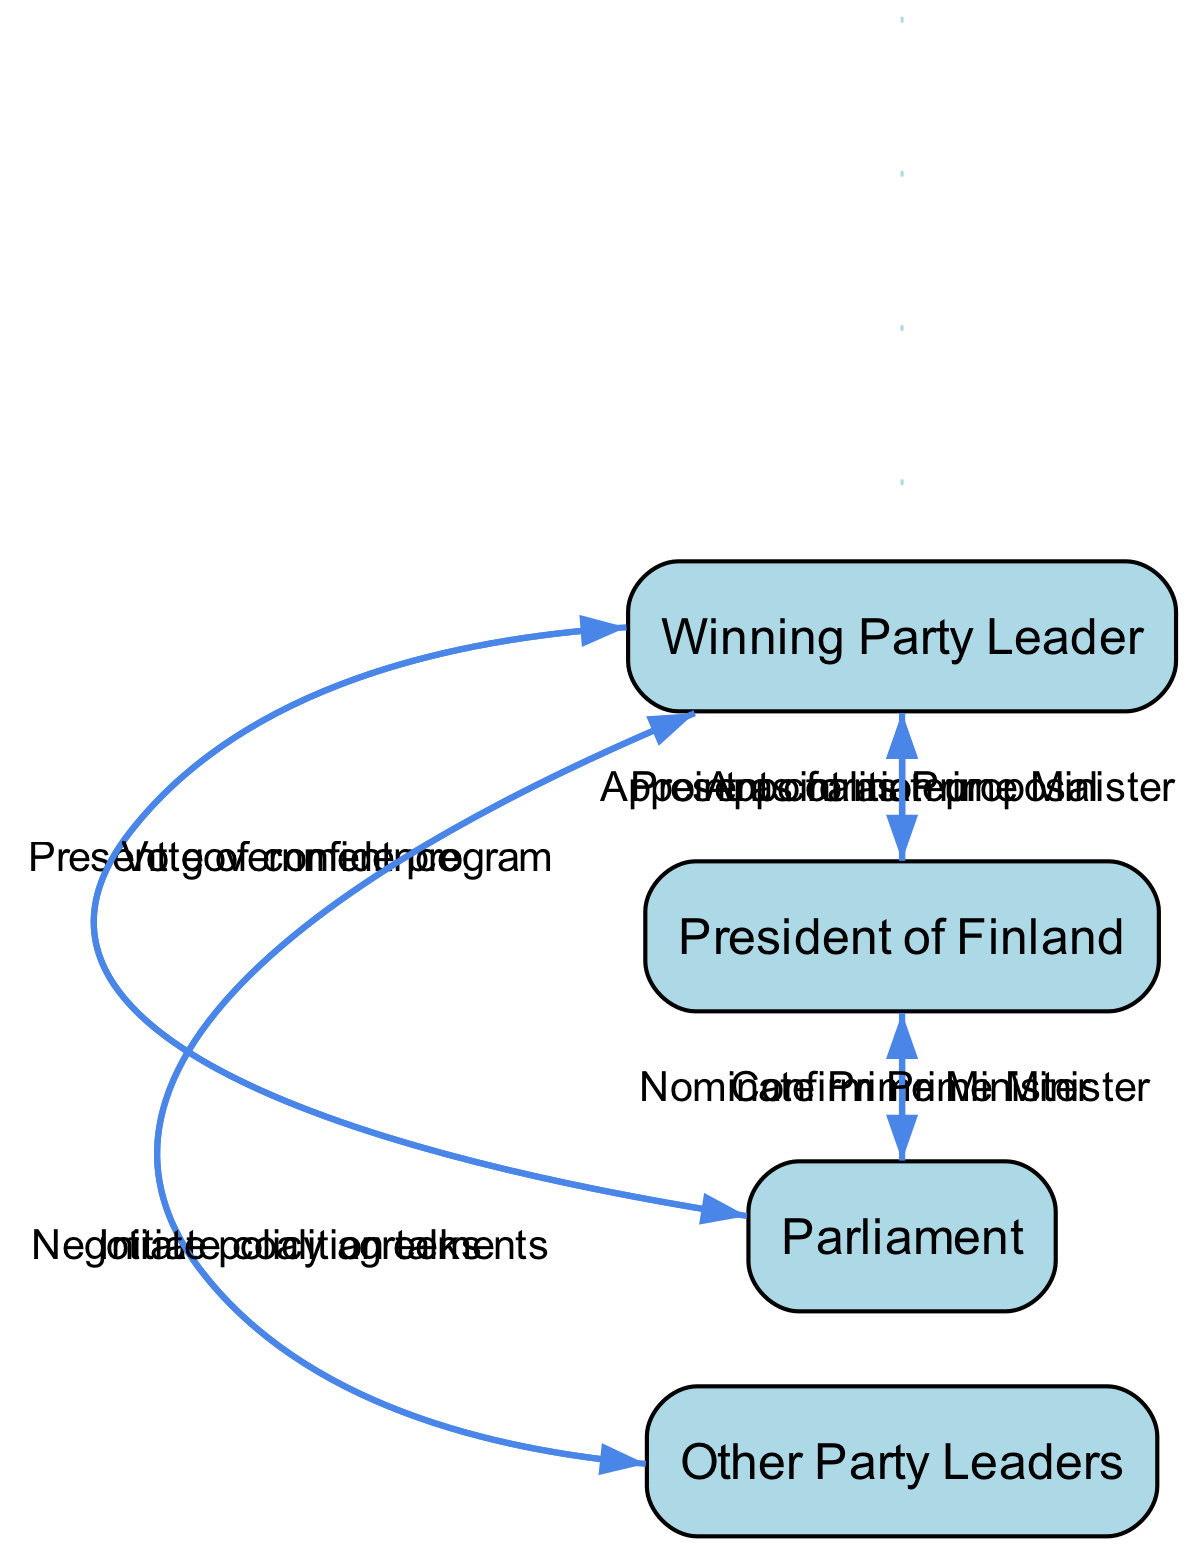What is the first action taken in the coalition formation process? The first action in the sequence is taken by the President of Finland, who appoints the Winning Party Leader as formateur. This action initiates the coalition formation process.
Answer: Appoint as formateur How many actors are involved in the diagram? There are four distinct actors identified within the process: the Winning Party Leader, President of Finland, Parliament, and Other Party Leaders. This count includes all main entities involved in forming the coalition government.
Answer: Four Which actor presents the coalition proposal? The Winning Party Leader is responsible for presenting the coalition proposal to the President of Finland. This step follows the negotiation phase with other party leaders.
Answer: Winning Party Leader What follows the nomination of the Prime Minister by the President? After the President of Finland nominates the Prime Minister, the Parliament confirms the Prime Minister. This action is crucial for legitimizing the Prime Minister's position.
Answer: Confirm Prime Minister Which action immediately follows the appointment of the Winning Party Leader as Prime Minister? After the Winning Party Leader is appointed as Prime Minister by the President, the next action is for the Winning Party Leader to present the government program to Parliament. This establishes the framework for the new government.
Answer: Present government program How many sequential actions occur before the vote of confidence? There are six actions leading up to the vote of confidence by Parliament, including appointments, proposals, and presentations, demonstrating the various steps in securing approval for the new government.
Answer: Six Which actor is involved at both the beginning and ending of the sequence? The President of Finland plays a key role at both the initiation and conclusion of the sequence, appointing the formateur and later appointing the new Prime Minister after parliamentary confirmation.
Answer: President of Finland What is the nature of the relationships indicated in the diagram? The relationships shown in the diagram depict a sequence of actions and approvals between actors necessary for forming the coalition government, illustrating a clear flow of responsibility and authority.
Answer: Sequence of actions Who negotiates policy agreements with the Winning Party Leader? Other Party Leaders engage in negotiations regarding policy agreements with the Winning Party Leader. This is a critical intermediary step in coalition discussions.
Answer: Other Party Leaders 